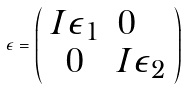<formula> <loc_0><loc_0><loc_500><loc_500>\epsilon = \left ( \begin{array} { c l c r } I \epsilon _ { 1 } & 0 \\ 0 & I \epsilon _ { 2 } \end{array} \right )</formula> 